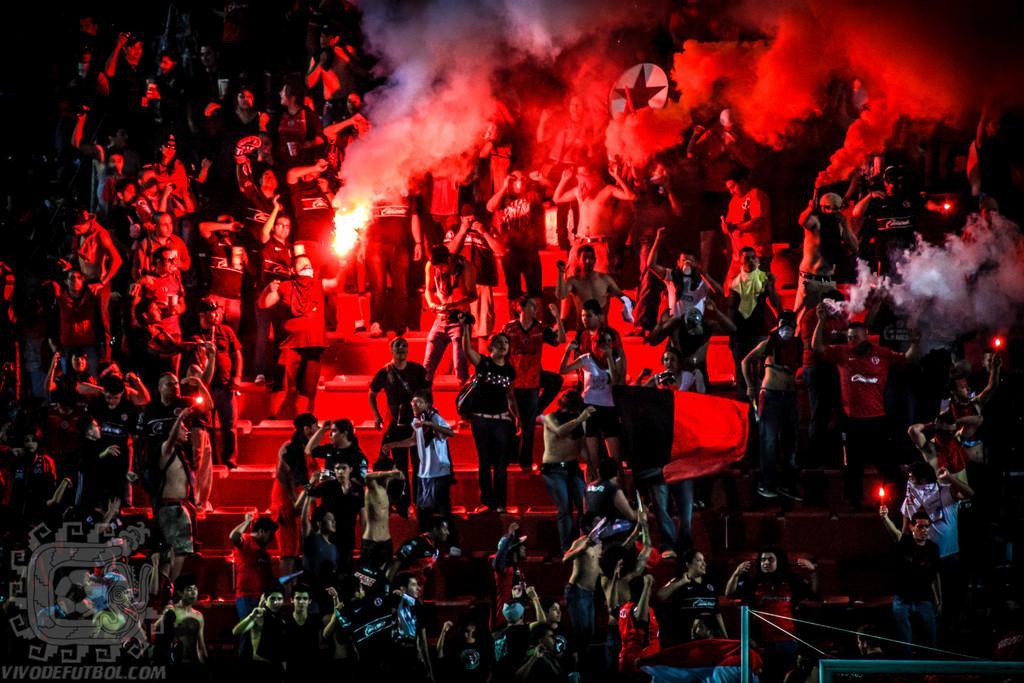Can you describe this image briefly? In this picture, we see many people are standing on the staircase. I think they are enjoying the party. In the background, we see the smoke. This picture might be clicked in the dark. 